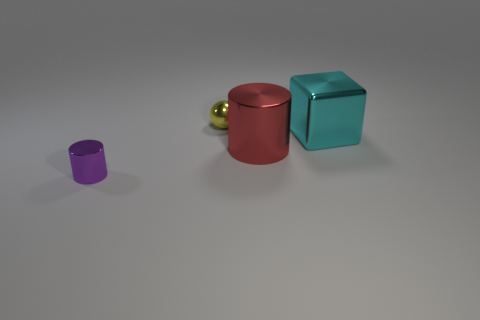There is a cyan metallic thing; is its size the same as the thing behind the big block?
Your answer should be compact. No. How many yellow metal spheres have the same size as the purple thing?
Give a very brief answer. 1. What number of tiny objects are either metal objects or yellow things?
Offer a terse response. 2. Are any large red cylinders visible?
Your response must be concise. Yes. Are there more things in front of the large metallic cylinder than large metal cubes that are behind the small yellow shiny object?
Your answer should be very brief. Yes. What color is the small object that is behind the metallic cylinder that is to the left of the red metallic thing?
Offer a very short reply. Yellow. What is the size of the shiny cylinder that is left of the red object that is to the right of the metallic thing that is behind the big metal block?
Your answer should be compact. Small. What is the shape of the small yellow thing?
Offer a terse response. Sphere. There is a tiny metallic thing that is behind the big red shiny object; how many small metallic things are on the right side of it?
Keep it short and to the point. 0. What number of other things are the same material as the tiny purple thing?
Provide a short and direct response. 3. 